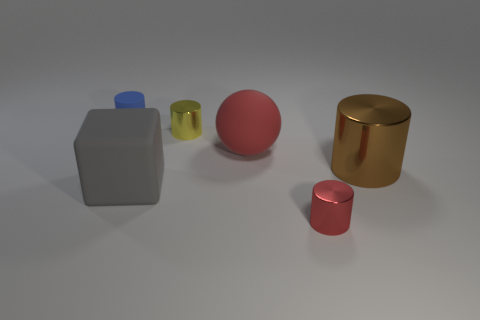Are there any balls made of the same material as the blue cylinder?
Your answer should be compact. Yes. Is the size of the red metallic cylinder the same as the yellow shiny object?
Give a very brief answer. Yes. What number of cylinders are either small yellow shiny things or large matte objects?
Provide a succinct answer. 1. There is a thing that is the same color as the sphere; what is it made of?
Offer a terse response. Metal. How many large brown objects have the same shape as the tiny yellow metallic thing?
Your response must be concise. 1. Are there more metallic objects in front of the red rubber sphere than tiny yellow cylinders that are behind the yellow metal cylinder?
Keep it short and to the point. Yes. There is a small shiny cylinder behind the red cylinder; does it have the same color as the tiny matte object?
Your response must be concise. No. What size is the yellow cylinder?
Provide a short and direct response. Small. There is a red thing that is the same size as the gray cube; what is it made of?
Give a very brief answer. Rubber. There is a shiny thing behind the large metallic cylinder; what is its color?
Offer a very short reply. Yellow. 